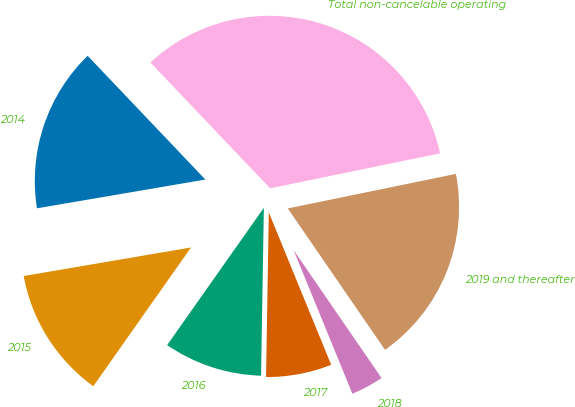Convert chart. <chart><loc_0><loc_0><loc_500><loc_500><pie_chart><fcel>2014<fcel>2015<fcel>2016<fcel>2017<fcel>2018<fcel>2019 and thereafter<fcel>Total non-cancelable operating<nl><fcel>15.59%<fcel>12.54%<fcel>9.5%<fcel>6.45%<fcel>3.4%<fcel>18.64%<fcel>33.87%<nl></chart> 